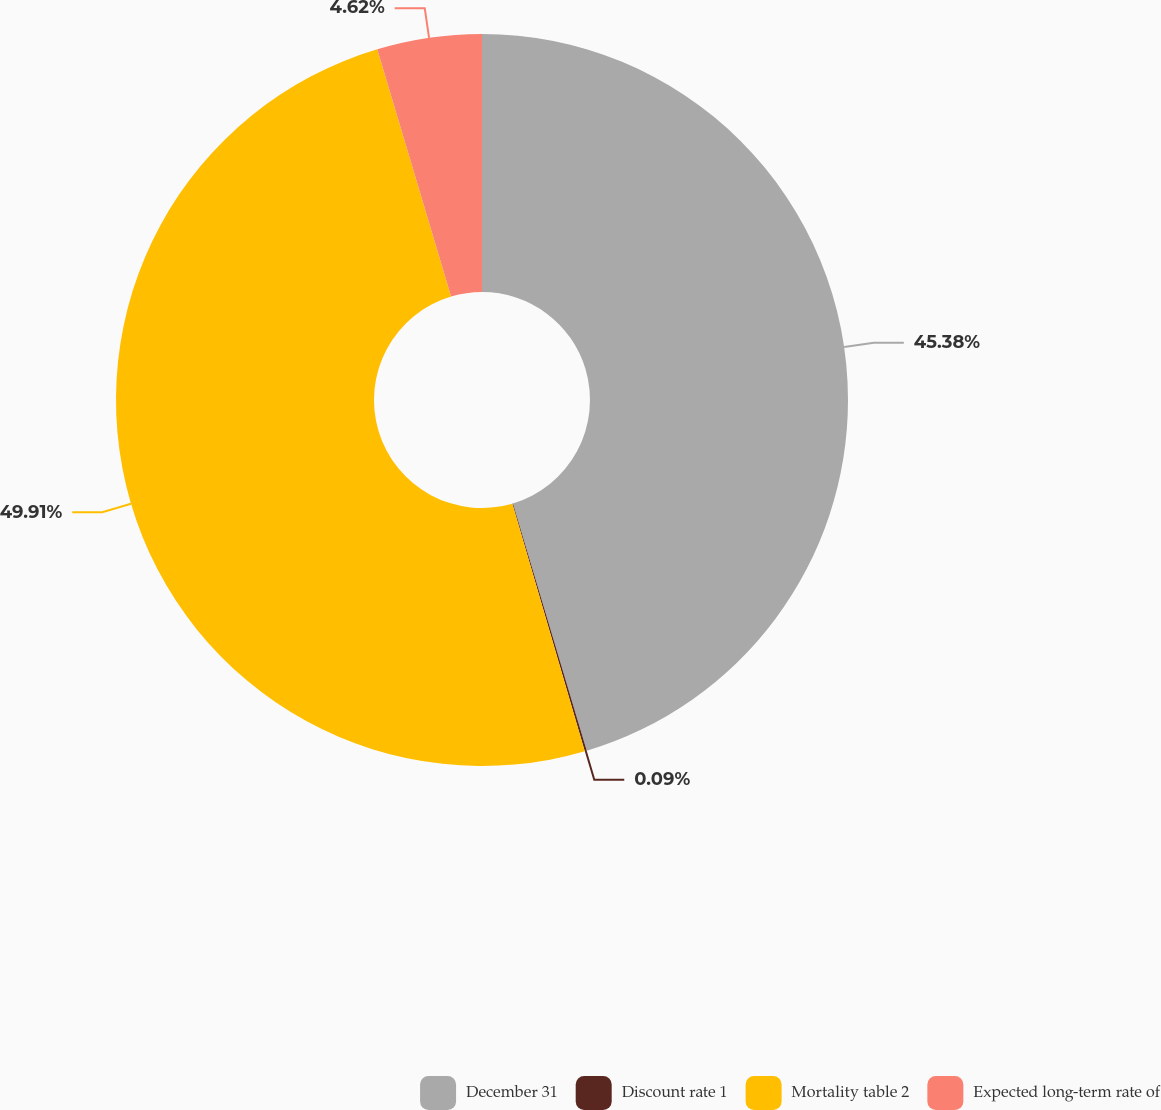<chart> <loc_0><loc_0><loc_500><loc_500><pie_chart><fcel>December 31<fcel>Discount rate 1<fcel>Mortality table 2<fcel>Expected long-term rate of<nl><fcel>45.38%<fcel>0.09%<fcel>49.91%<fcel>4.62%<nl></chart> 